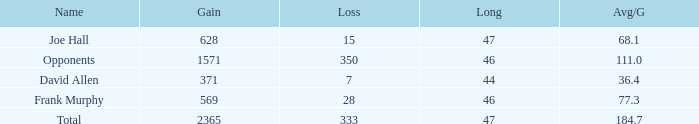Which Avg/G is the lowest one that has a Long smaller than 47, and a Name of frank murphy, and a Gain smaller than 569? None. 